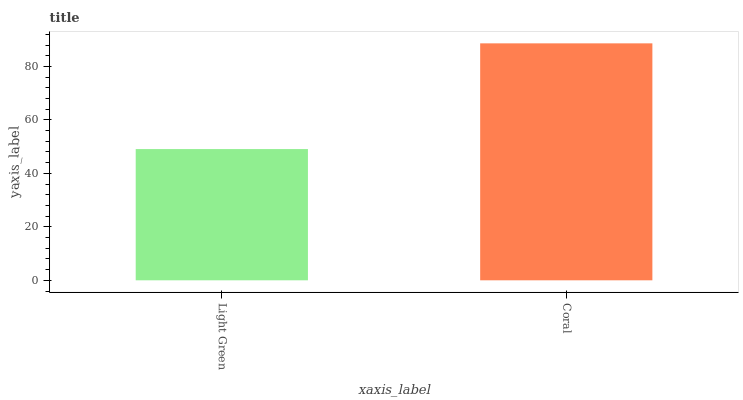Is Light Green the minimum?
Answer yes or no. Yes. Is Coral the maximum?
Answer yes or no. Yes. Is Coral the minimum?
Answer yes or no. No. Is Coral greater than Light Green?
Answer yes or no. Yes. Is Light Green less than Coral?
Answer yes or no. Yes. Is Light Green greater than Coral?
Answer yes or no. No. Is Coral less than Light Green?
Answer yes or no. No. Is Coral the high median?
Answer yes or no. Yes. Is Light Green the low median?
Answer yes or no. Yes. Is Light Green the high median?
Answer yes or no. No. Is Coral the low median?
Answer yes or no. No. 